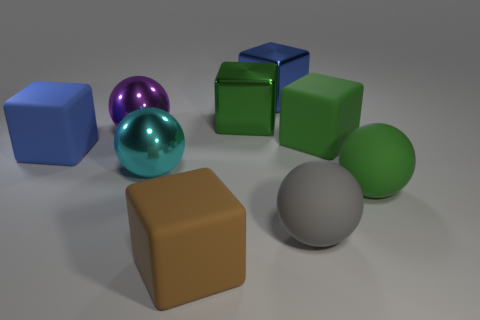If I were to place a new yellow rubber duck into the scene, where would it fit in without obscuring any other objects? A new yellow rubber duck could fit in on the front left side of the image, near the brown cube, where there's empty space. This placement would allow the duck to be visible without blocking any other objects in the scene. Would the duck's texture stand out in this group of objects? Absolutely, the yellow rubber duck would have a more pronounced, semi-gloss texture compared to the other objects, which are either highly reflective or have a matte finish. It would introduce both a new color and a unique material quality to the assortment. 